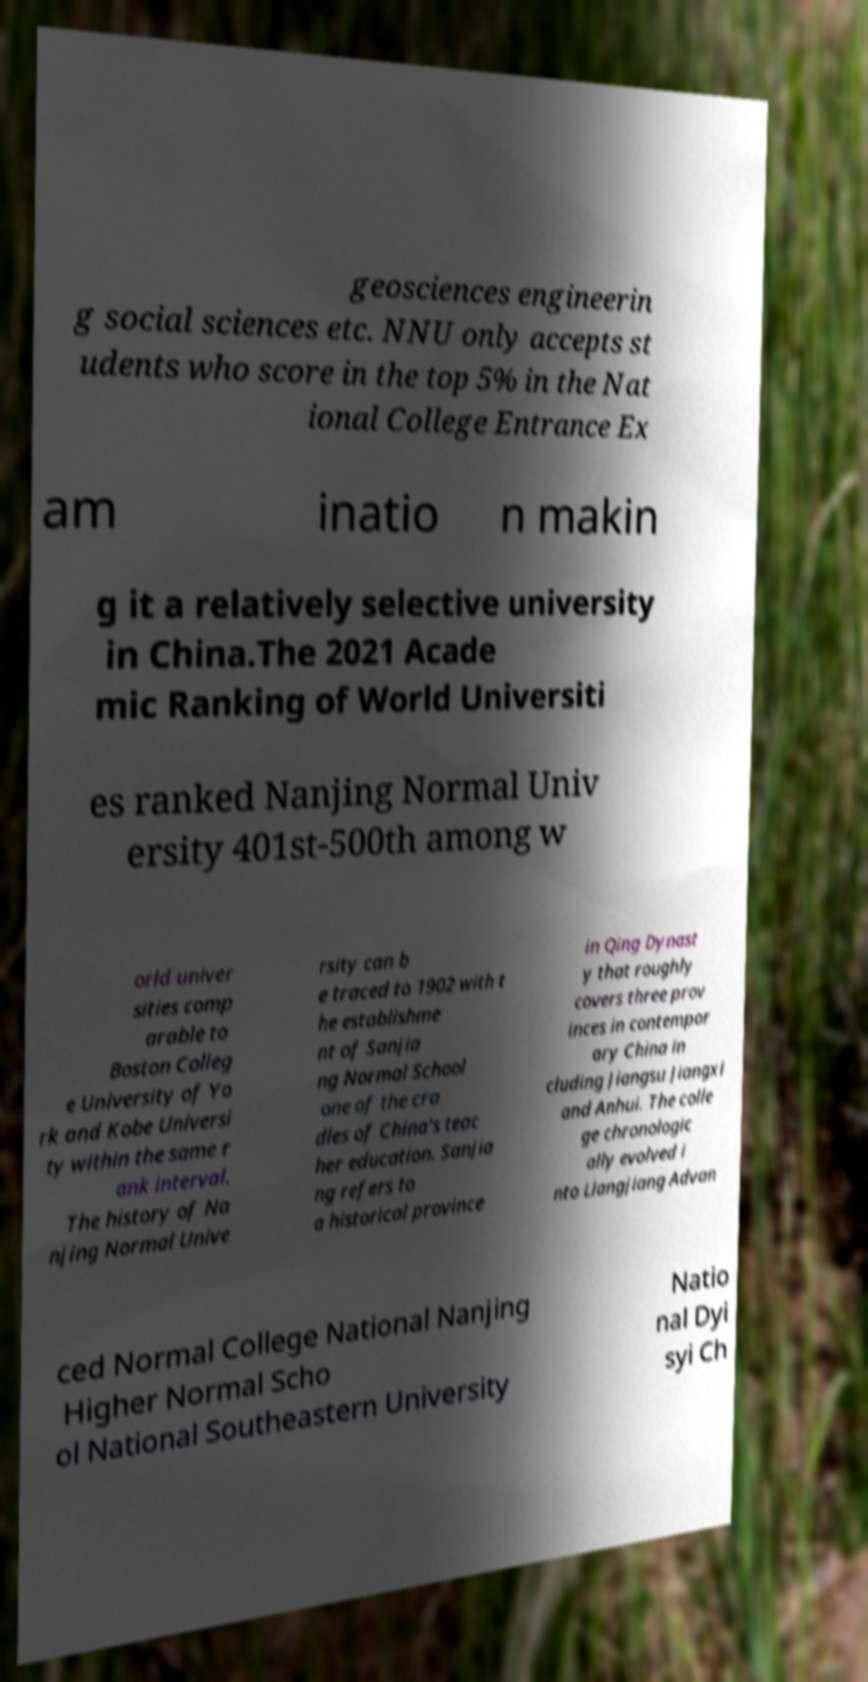Could you assist in decoding the text presented in this image and type it out clearly? geosciences engineerin g social sciences etc. NNU only accepts st udents who score in the top 5% in the Nat ional College Entrance Ex am inatio n makin g it a relatively selective university in China.The 2021 Acade mic Ranking of World Universiti es ranked Nanjing Normal Univ ersity 401st-500th among w orld univer sities comp arable to Boston Colleg e University of Yo rk and Kobe Universi ty within the same r ank interval. The history of Na njing Normal Unive rsity can b e traced to 1902 with t he establishme nt of Sanjia ng Normal School one of the cra dles of China's teac her education. Sanjia ng refers to a historical province in Qing Dynast y that roughly covers three prov inces in contempor ary China in cluding Jiangsu Jiangxi and Anhui. The colle ge chronologic ally evolved i nto Liangjiang Advan ced Normal College National Nanjing Higher Normal Scho ol National Southeastern University Natio nal Dyi syi Ch 